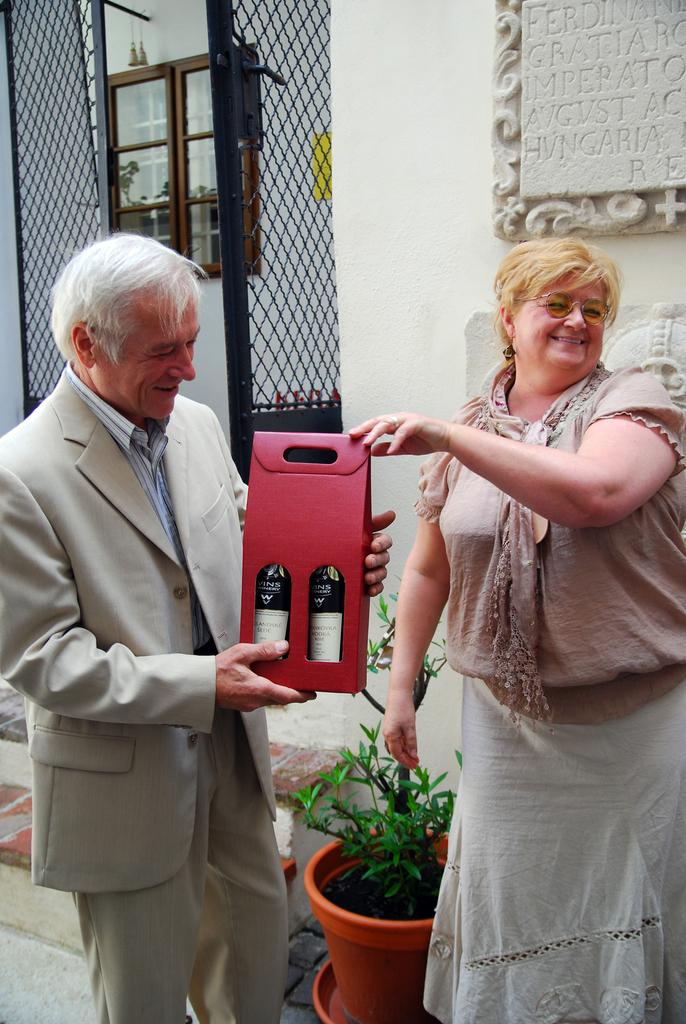Who is the main subject in the image? There is a woman in the image. What is the woman doing in the image? The woman is giving a box to a man. Who is the other person in the image? There is a man in the image. What can be seen in the background of the image? There is a flower pot, a plant, a gate, cupboards, and a wall in the background. How many girls are present in the image? There are no girls present in the image; it features a woman and a man. What type of fuel is being used by the writer in the image? There is no writer or fuel present in the image. 